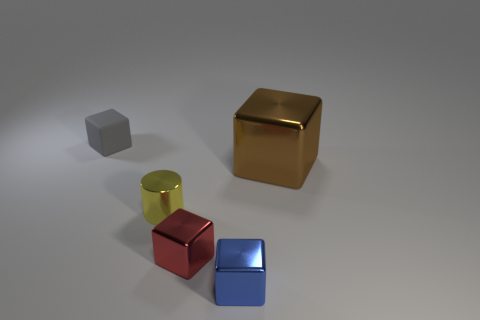Subtract all brown cylinders. Subtract all blue cubes. How many cylinders are left? 1 Subtract all purple spheres. How many brown cylinders are left? 0 Add 3 browns. How many tiny things exist? 0 Subtract all brown metal cubes. Subtract all red things. How many objects are left? 3 Add 4 yellow objects. How many yellow objects are left? 5 Add 2 brown things. How many brown things exist? 3 Add 2 small green matte balls. How many objects exist? 7 Subtract all brown blocks. How many blocks are left? 3 Subtract all red blocks. How many blocks are left? 3 Subtract 0 blue spheres. How many objects are left? 5 